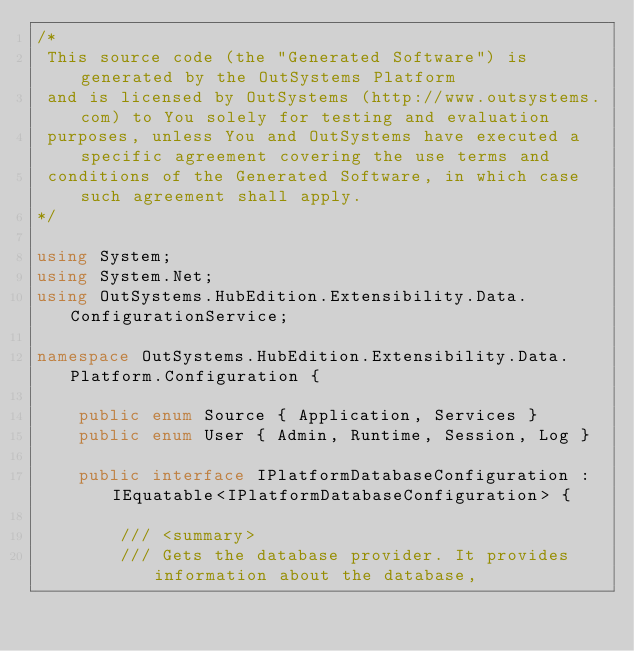Convert code to text. <code><loc_0><loc_0><loc_500><loc_500><_C#_>/* 
 This source code (the "Generated Software") is generated by the OutSystems Platform 
 and is licensed by OutSystems (http://www.outsystems.com) to You solely for testing and evaluation 
 purposes, unless You and OutSystems have executed a specific agreement covering the use terms and 
 conditions of the Generated Software, in which case such agreement shall apply. 
*/

using System;
using System.Net;
using OutSystems.HubEdition.Extensibility.Data.ConfigurationService;

namespace OutSystems.HubEdition.Extensibility.Data.Platform.Configuration {

    public enum Source { Application, Services }
    public enum User { Admin, Runtime, Session, Log }

    public interface IPlatformDatabaseConfiguration : IEquatable<IPlatformDatabaseConfiguration> {

        /// <summary>
        /// Gets the database provider. It provides information about the database,</code> 